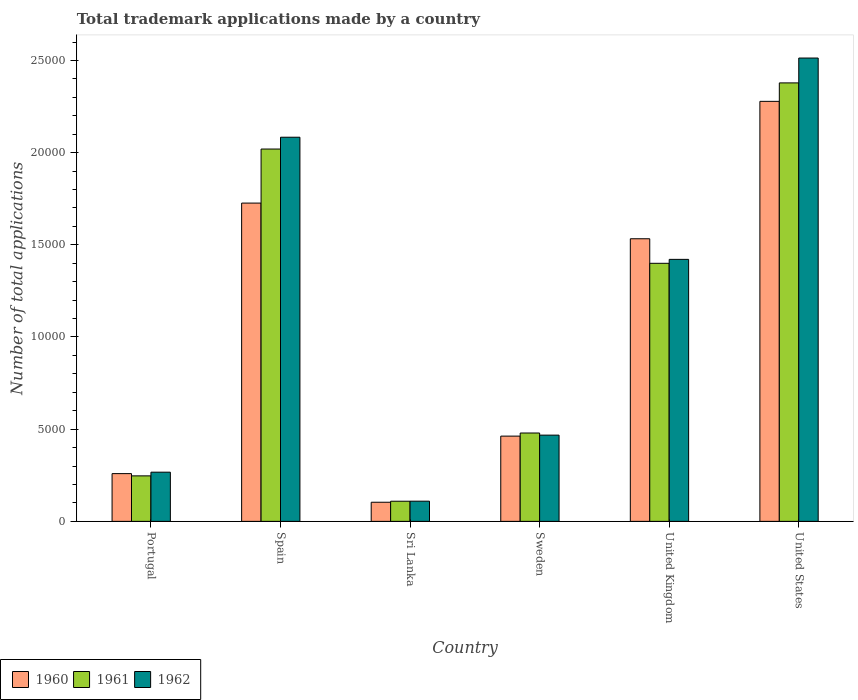How many groups of bars are there?
Offer a terse response. 6. How many bars are there on the 3rd tick from the right?
Give a very brief answer. 3. What is the label of the 2nd group of bars from the left?
Give a very brief answer. Spain. In how many cases, is the number of bars for a given country not equal to the number of legend labels?
Provide a short and direct response. 0. What is the number of applications made by in 1960 in Sweden?
Ensure brevity in your answer.  4624. Across all countries, what is the maximum number of applications made by in 1961?
Offer a very short reply. 2.38e+04. Across all countries, what is the minimum number of applications made by in 1960?
Offer a terse response. 1037. In which country was the number of applications made by in 1961 maximum?
Your answer should be compact. United States. In which country was the number of applications made by in 1960 minimum?
Your answer should be compact. Sri Lanka. What is the total number of applications made by in 1960 in the graph?
Provide a short and direct response. 6.36e+04. What is the difference between the number of applications made by in 1961 in Spain and that in Sweden?
Offer a very short reply. 1.54e+04. What is the difference between the number of applications made by in 1962 in Portugal and the number of applications made by in 1961 in United Kingdom?
Provide a succinct answer. -1.13e+04. What is the average number of applications made by in 1960 per country?
Keep it short and to the point. 1.06e+04. What is the difference between the number of applications made by of/in 1962 and number of applications made by of/in 1961 in Portugal?
Ensure brevity in your answer.  200. What is the ratio of the number of applications made by in 1962 in Portugal to that in Sweden?
Offer a terse response. 0.57. Is the difference between the number of applications made by in 1962 in Spain and Sri Lanka greater than the difference between the number of applications made by in 1961 in Spain and Sri Lanka?
Your answer should be compact. Yes. What is the difference between the highest and the second highest number of applications made by in 1961?
Give a very brief answer. 6197. What is the difference between the highest and the lowest number of applications made by in 1961?
Make the answer very short. 2.27e+04. Is the sum of the number of applications made by in 1961 in Sweden and United Kingdom greater than the maximum number of applications made by in 1960 across all countries?
Give a very brief answer. No. What does the 3rd bar from the right in Spain represents?
Provide a succinct answer. 1960. How many bars are there?
Offer a very short reply. 18. Are all the bars in the graph horizontal?
Offer a terse response. No. How many countries are there in the graph?
Ensure brevity in your answer.  6. Where does the legend appear in the graph?
Make the answer very short. Bottom left. How many legend labels are there?
Give a very brief answer. 3. What is the title of the graph?
Your answer should be compact. Total trademark applications made by a country. What is the label or title of the Y-axis?
Your response must be concise. Number of total applications. What is the Number of total applications in 1960 in Portugal?
Make the answer very short. 2590. What is the Number of total applications in 1961 in Portugal?
Ensure brevity in your answer.  2468. What is the Number of total applications of 1962 in Portugal?
Give a very brief answer. 2668. What is the Number of total applications in 1960 in Spain?
Provide a succinct answer. 1.73e+04. What is the Number of total applications in 1961 in Spain?
Your answer should be compact. 2.02e+04. What is the Number of total applications of 1962 in Spain?
Your response must be concise. 2.08e+04. What is the Number of total applications of 1960 in Sri Lanka?
Keep it short and to the point. 1037. What is the Number of total applications in 1961 in Sri Lanka?
Make the answer very short. 1092. What is the Number of total applications of 1962 in Sri Lanka?
Offer a very short reply. 1095. What is the Number of total applications of 1960 in Sweden?
Offer a very short reply. 4624. What is the Number of total applications in 1961 in Sweden?
Give a very brief answer. 4792. What is the Number of total applications in 1962 in Sweden?
Provide a short and direct response. 4677. What is the Number of total applications in 1960 in United Kingdom?
Make the answer very short. 1.53e+04. What is the Number of total applications in 1961 in United Kingdom?
Your answer should be very brief. 1.40e+04. What is the Number of total applications of 1962 in United Kingdom?
Ensure brevity in your answer.  1.42e+04. What is the Number of total applications of 1960 in United States?
Give a very brief answer. 2.28e+04. What is the Number of total applications in 1961 in United States?
Make the answer very short. 2.38e+04. What is the Number of total applications of 1962 in United States?
Your answer should be compact. 2.51e+04. Across all countries, what is the maximum Number of total applications of 1960?
Keep it short and to the point. 2.28e+04. Across all countries, what is the maximum Number of total applications in 1961?
Provide a short and direct response. 2.38e+04. Across all countries, what is the maximum Number of total applications in 1962?
Your answer should be very brief. 2.51e+04. Across all countries, what is the minimum Number of total applications of 1960?
Your answer should be very brief. 1037. Across all countries, what is the minimum Number of total applications of 1961?
Give a very brief answer. 1092. Across all countries, what is the minimum Number of total applications of 1962?
Make the answer very short. 1095. What is the total Number of total applications in 1960 in the graph?
Keep it short and to the point. 6.36e+04. What is the total Number of total applications of 1961 in the graph?
Make the answer very short. 6.63e+04. What is the total Number of total applications in 1962 in the graph?
Give a very brief answer. 6.86e+04. What is the difference between the Number of total applications in 1960 in Portugal and that in Spain?
Provide a succinct answer. -1.47e+04. What is the difference between the Number of total applications of 1961 in Portugal and that in Spain?
Your response must be concise. -1.77e+04. What is the difference between the Number of total applications in 1962 in Portugal and that in Spain?
Ensure brevity in your answer.  -1.82e+04. What is the difference between the Number of total applications in 1960 in Portugal and that in Sri Lanka?
Your answer should be very brief. 1553. What is the difference between the Number of total applications in 1961 in Portugal and that in Sri Lanka?
Offer a very short reply. 1376. What is the difference between the Number of total applications of 1962 in Portugal and that in Sri Lanka?
Offer a terse response. 1573. What is the difference between the Number of total applications in 1960 in Portugal and that in Sweden?
Give a very brief answer. -2034. What is the difference between the Number of total applications of 1961 in Portugal and that in Sweden?
Give a very brief answer. -2324. What is the difference between the Number of total applications of 1962 in Portugal and that in Sweden?
Your response must be concise. -2009. What is the difference between the Number of total applications of 1960 in Portugal and that in United Kingdom?
Give a very brief answer. -1.27e+04. What is the difference between the Number of total applications in 1961 in Portugal and that in United Kingdom?
Your response must be concise. -1.15e+04. What is the difference between the Number of total applications in 1962 in Portugal and that in United Kingdom?
Keep it short and to the point. -1.15e+04. What is the difference between the Number of total applications of 1960 in Portugal and that in United States?
Offer a terse response. -2.02e+04. What is the difference between the Number of total applications of 1961 in Portugal and that in United States?
Provide a short and direct response. -2.13e+04. What is the difference between the Number of total applications in 1962 in Portugal and that in United States?
Your response must be concise. -2.25e+04. What is the difference between the Number of total applications in 1960 in Spain and that in Sri Lanka?
Provide a short and direct response. 1.62e+04. What is the difference between the Number of total applications of 1961 in Spain and that in Sri Lanka?
Ensure brevity in your answer.  1.91e+04. What is the difference between the Number of total applications in 1962 in Spain and that in Sri Lanka?
Provide a succinct answer. 1.97e+04. What is the difference between the Number of total applications in 1960 in Spain and that in Sweden?
Your answer should be very brief. 1.26e+04. What is the difference between the Number of total applications of 1961 in Spain and that in Sweden?
Provide a succinct answer. 1.54e+04. What is the difference between the Number of total applications in 1962 in Spain and that in Sweden?
Your answer should be very brief. 1.62e+04. What is the difference between the Number of total applications in 1960 in Spain and that in United Kingdom?
Keep it short and to the point. 1935. What is the difference between the Number of total applications of 1961 in Spain and that in United Kingdom?
Offer a very short reply. 6197. What is the difference between the Number of total applications in 1962 in Spain and that in United Kingdom?
Ensure brevity in your answer.  6625. What is the difference between the Number of total applications in 1960 in Spain and that in United States?
Offer a very short reply. -5518. What is the difference between the Number of total applications of 1961 in Spain and that in United States?
Provide a short and direct response. -3588. What is the difference between the Number of total applications in 1962 in Spain and that in United States?
Your response must be concise. -4295. What is the difference between the Number of total applications in 1960 in Sri Lanka and that in Sweden?
Your response must be concise. -3587. What is the difference between the Number of total applications in 1961 in Sri Lanka and that in Sweden?
Offer a terse response. -3700. What is the difference between the Number of total applications in 1962 in Sri Lanka and that in Sweden?
Your answer should be compact. -3582. What is the difference between the Number of total applications in 1960 in Sri Lanka and that in United Kingdom?
Provide a short and direct response. -1.43e+04. What is the difference between the Number of total applications in 1961 in Sri Lanka and that in United Kingdom?
Provide a succinct answer. -1.29e+04. What is the difference between the Number of total applications in 1962 in Sri Lanka and that in United Kingdom?
Ensure brevity in your answer.  -1.31e+04. What is the difference between the Number of total applications of 1960 in Sri Lanka and that in United States?
Keep it short and to the point. -2.17e+04. What is the difference between the Number of total applications in 1961 in Sri Lanka and that in United States?
Provide a succinct answer. -2.27e+04. What is the difference between the Number of total applications of 1962 in Sri Lanka and that in United States?
Make the answer very short. -2.40e+04. What is the difference between the Number of total applications in 1960 in Sweden and that in United Kingdom?
Make the answer very short. -1.07e+04. What is the difference between the Number of total applications in 1961 in Sweden and that in United Kingdom?
Make the answer very short. -9205. What is the difference between the Number of total applications in 1962 in Sweden and that in United Kingdom?
Make the answer very short. -9533. What is the difference between the Number of total applications in 1960 in Sweden and that in United States?
Make the answer very short. -1.82e+04. What is the difference between the Number of total applications of 1961 in Sweden and that in United States?
Offer a very short reply. -1.90e+04. What is the difference between the Number of total applications of 1962 in Sweden and that in United States?
Offer a terse response. -2.05e+04. What is the difference between the Number of total applications of 1960 in United Kingdom and that in United States?
Your answer should be compact. -7453. What is the difference between the Number of total applications in 1961 in United Kingdom and that in United States?
Your answer should be very brief. -9785. What is the difference between the Number of total applications in 1962 in United Kingdom and that in United States?
Your response must be concise. -1.09e+04. What is the difference between the Number of total applications of 1960 in Portugal and the Number of total applications of 1961 in Spain?
Ensure brevity in your answer.  -1.76e+04. What is the difference between the Number of total applications in 1960 in Portugal and the Number of total applications in 1962 in Spain?
Ensure brevity in your answer.  -1.82e+04. What is the difference between the Number of total applications in 1961 in Portugal and the Number of total applications in 1962 in Spain?
Keep it short and to the point. -1.84e+04. What is the difference between the Number of total applications in 1960 in Portugal and the Number of total applications in 1961 in Sri Lanka?
Your response must be concise. 1498. What is the difference between the Number of total applications of 1960 in Portugal and the Number of total applications of 1962 in Sri Lanka?
Offer a terse response. 1495. What is the difference between the Number of total applications of 1961 in Portugal and the Number of total applications of 1962 in Sri Lanka?
Keep it short and to the point. 1373. What is the difference between the Number of total applications in 1960 in Portugal and the Number of total applications in 1961 in Sweden?
Ensure brevity in your answer.  -2202. What is the difference between the Number of total applications in 1960 in Portugal and the Number of total applications in 1962 in Sweden?
Provide a short and direct response. -2087. What is the difference between the Number of total applications of 1961 in Portugal and the Number of total applications of 1962 in Sweden?
Your answer should be very brief. -2209. What is the difference between the Number of total applications in 1960 in Portugal and the Number of total applications in 1961 in United Kingdom?
Give a very brief answer. -1.14e+04. What is the difference between the Number of total applications of 1960 in Portugal and the Number of total applications of 1962 in United Kingdom?
Give a very brief answer. -1.16e+04. What is the difference between the Number of total applications in 1961 in Portugal and the Number of total applications in 1962 in United Kingdom?
Your answer should be compact. -1.17e+04. What is the difference between the Number of total applications of 1960 in Portugal and the Number of total applications of 1961 in United States?
Your response must be concise. -2.12e+04. What is the difference between the Number of total applications in 1960 in Portugal and the Number of total applications in 1962 in United States?
Keep it short and to the point. -2.25e+04. What is the difference between the Number of total applications in 1961 in Portugal and the Number of total applications in 1962 in United States?
Ensure brevity in your answer.  -2.27e+04. What is the difference between the Number of total applications of 1960 in Spain and the Number of total applications of 1961 in Sri Lanka?
Ensure brevity in your answer.  1.62e+04. What is the difference between the Number of total applications of 1960 in Spain and the Number of total applications of 1962 in Sri Lanka?
Your answer should be very brief. 1.62e+04. What is the difference between the Number of total applications of 1961 in Spain and the Number of total applications of 1962 in Sri Lanka?
Your answer should be very brief. 1.91e+04. What is the difference between the Number of total applications in 1960 in Spain and the Number of total applications in 1961 in Sweden?
Offer a very short reply. 1.25e+04. What is the difference between the Number of total applications in 1960 in Spain and the Number of total applications in 1962 in Sweden?
Offer a very short reply. 1.26e+04. What is the difference between the Number of total applications in 1961 in Spain and the Number of total applications in 1962 in Sweden?
Ensure brevity in your answer.  1.55e+04. What is the difference between the Number of total applications of 1960 in Spain and the Number of total applications of 1961 in United Kingdom?
Your answer should be compact. 3266. What is the difference between the Number of total applications in 1960 in Spain and the Number of total applications in 1962 in United Kingdom?
Your answer should be very brief. 3053. What is the difference between the Number of total applications in 1961 in Spain and the Number of total applications in 1962 in United Kingdom?
Give a very brief answer. 5984. What is the difference between the Number of total applications of 1960 in Spain and the Number of total applications of 1961 in United States?
Offer a very short reply. -6519. What is the difference between the Number of total applications in 1960 in Spain and the Number of total applications in 1962 in United States?
Give a very brief answer. -7867. What is the difference between the Number of total applications in 1961 in Spain and the Number of total applications in 1962 in United States?
Give a very brief answer. -4936. What is the difference between the Number of total applications of 1960 in Sri Lanka and the Number of total applications of 1961 in Sweden?
Give a very brief answer. -3755. What is the difference between the Number of total applications in 1960 in Sri Lanka and the Number of total applications in 1962 in Sweden?
Provide a succinct answer. -3640. What is the difference between the Number of total applications of 1961 in Sri Lanka and the Number of total applications of 1962 in Sweden?
Your answer should be compact. -3585. What is the difference between the Number of total applications of 1960 in Sri Lanka and the Number of total applications of 1961 in United Kingdom?
Make the answer very short. -1.30e+04. What is the difference between the Number of total applications of 1960 in Sri Lanka and the Number of total applications of 1962 in United Kingdom?
Make the answer very short. -1.32e+04. What is the difference between the Number of total applications in 1961 in Sri Lanka and the Number of total applications in 1962 in United Kingdom?
Provide a short and direct response. -1.31e+04. What is the difference between the Number of total applications of 1960 in Sri Lanka and the Number of total applications of 1961 in United States?
Ensure brevity in your answer.  -2.27e+04. What is the difference between the Number of total applications in 1960 in Sri Lanka and the Number of total applications in 1962 in United States?
Your answer should be very brief. -2.41e+04. What is the difference between the Number of total applications of 1961 in Sri Lanka and the Number of total applications of 1962 in United States?
Offer a very short reply. -2.40e+04. What is the difference between the Number of total applications of 1960 in Sweden and the Number of total applications of 1961 in United Kingdom?
Your answer should be very brief. -9373. What is the difference between the Number of total applications in 1960 in Sweden and the Number of total applications in 1962 in United Kingdom?
Keep it short and to the point. -9586. What is the difference between the Number of total applications of 1961 in Sweden and the Number of total applications of 1962 in United Kingdom?
Offer a very short reply. -9418. What is the difference between the Number of total applications in 1960 in Sweden and the Number of total applications in 1961 in United States?
Your response must be concise. -1.92e+04. What is the difference between the Number of total applications of 1960 in Sweden and the Number of total applications of 1962 in United States?
Your answer should be compact. -2.05e+04. What is the difference between the Number of total applications in 1961 in Sweden and the Number of total applications in 1962 in United States?
Offer a very short reply. -2.03e+04. What is the difference between the Number of total applications of 1960 in United Kingdom and the Number of total applications of 1961 in United States?
Make the answer very short. -8454. What is the difference between the Number of total applications in 1960 in United Kingdom and the Number of total applications in 1962 in United States?
Your answer should be compact. -9802. What is the difference between the Number of total applications of 1961 in United Kingdom and the Number of total applications of 1962 in United States?
Make the answer very short. -1.11e+04. What is the average Number of total applications in 1960 per country?
Provide a short and direct response. 1.06e+04. What is the average Number of total applications of 1961 per country?
Offer a terse response. 1.11e+04. What is the average Number of total applications in 1962 per country?
Offer a very short reply. 1.14e+04. What is the difference between the Number of total applications in 1960 and Number of total applications in 1961 in Portugal?
Make the answer very short. 122. What is the difference between the Number of total applications in 1960 and Number of total applications in 1962 in Portugal?
Your response must be concise. -78. What is the difference between the Number of total applications in 1961 and Number of total applications in 1962 in Portugal?
Your answer should be very brief. -200. What is the difference between the Number of total applications in 1960 and Number of total applications in 1961 in Spain?
Your answer should be very brief. -2931. What is the difference between the Number of total applications of 1960 and Number of total applications of 1962 in Spain?
Offer a terse response. -3572. What is the difference between the Number of total applications of 1961 and Number of total applications of 1962 in Spain?
Give a very brief answer. -641. What is the difference between the Number of total applications of 1960 and Number of total applications of 1961 in Sri Lanka?
Give a very brief answer. -55. What is the difference between the Number of total applications in 1960 and Number of total applications in 1962 in Sri Lanka?
Ensure brevity in your answer.  -58. What is the difference between the Number of total applications of 1960 and Number of total applications of 1961 in Sweden?
Your answer should be compact. -168. What is the difference between the Number of total applications in 1960 and Number of total applications in 1962 in Sweden?
Offer a very short reply. -53. What is the difference between the Number of total applications in 1961 and Number of total applications in 1962 in Sweden?
Give a very brief answer. 115. What is the difference between the Number of total applications of 1960 and Number of total applications of 1961 in United Kingdom?
Offer a terse response. 1331. What is the difference between the Number of total applications in 1960 and Number of total applications in 1962 in United Kingdom?
Provide a succinct answer. 1118. What is the difference between the Number of total applications of 1961 and Number of total applications of 1962 in United Kingdom?
Give a very brief answer. -213. What is the difference between the Number of total applications of 1960 and Number of total applications of 1961 in United States?
Offer a terse response. -1001. What is the difference between the Number of total applications in 1960 and Number of total applications in 1962 in United States?
Your answer should be very brief. -2349. What is the difference between the Number of total applications in 1961 and Number of total applications in 1962 in United States?
Provide a succinct answer. -1348. What is the ratio of the Number of total applications of 1960 in Portugal to that in Spain?
Your answer should be compact. 0.15. What is the ratio of the Number of total applications of 1961 in Portugal to that in Spain?
Offer a terse response. 0.12. What is the ratio of the Number of total applications of 1962 in Portugal to that in Spain?
Ensure brevity in your answer.  0.13. What is the ratio of the Number of total applications of 1960 in Portugal to that in Sri Lanka?
Offer a terse response. 2.5. What is the ratio of the Number of total applications in 1961 in Portugal to that in Sri Lanka?
Your answer should be very brief. 2.26. What is the ratio of the Number of total applications in 1962 in Portugal to that in Sri Lanka?
Your answer should be compact. 2.44. What is the ratio of the Number of total applications of 1960 in Portugal to that in Sweden?
Provide a short and direct response. 0.56. What is the ratio of the Number of total applications in 1961 in Portugal to that in Sweden?
Your response must be concise. 0.52. What is the ratio of the Number of total applications of 1962 in Portugal to that in Sweden?
Ensure brevity in your answer.  0.57. What is the ratio of the Number of total applications of 1960 in Portugal to that in United Kingdom?
Make the answer very short. 0.17. What is the ratio of the Number of total applications in 1961 in Portugal to that in United Kingdom?
Keep it short and to the point. 0.18. What is the ratio of the Number of total applications of 1962 in Portugal to that in United Kingdom?
Your response must be concise. 0.19. What is the ratio of the Number of total applications in 1960 in Portugal to that in United States?
Ensure brevity in your answer.  0.11. What is the ratio of the Number of total applications in 1961 in Portugal to that in United States?
Make the answer very short. 0.1. What is the ratio of the Number of total applications in 1962 in Portugal to that in United States?
Ensure brevity in your answer.  0.11. What is the ratio of the Number of total applications of 1960 in Spain to that in Sri Lanka?
Your answer should be very brief. 16.65. What is the ratio of the Number of total applications in 1961 in Spain to that in Sri Lanka?
Offer a terse response. 18.49. What is the ratio of the Number of total applications of 1962 in Spain to that in Sri Lanka?
Keep it short and to the point. 19.03. What is the ratio of the Number of total applications in 1960 in Spain to that in Sweden?
Provide a succinct answer. 3.73. What is the ratio of the Number of total applications in 1961 in Spain to that in Sweden?
Offer a very short reply. 4.21. What is the ratio of the Number of total applications in 1962 in Spain to that in Sweden?
Provide a succinct answer. 4.45. What is the ratio of the Number of total applications in 1960 in Spain to that in United Kingdom?
Make the answer very short. 1.13. What is the ratio of the Number of total applications in 1961 in Spain to that in United Kingdom?
Offer a terse response. 1.44. What is the ratio of the Number of total applications of 1962 in Spain to that in United Kingdom?
Your answer should be compact. 1.47. What is the ratio of the Number of total applications in 1960 in Spain to that in United States?
Provide a short and direct response. 0.76. What is the ratio of the Number of total applications in 1961 in Spain to that in United States?
Give a very brief answer. 0.85. What is the ratio of the Number of total applications of 1962 in Spain to that in United States?
Your answer should be very brief. 0.83. What is the ratio of the Number of total applications of 1960 in Sri Lanka to that in Sweden?
Your answer should be very brief. 0.22. What is the ratio of the Number of total applications of 1961 in Sri Lanka to that in Sweden?
Ensure brevity in your answer.  0.23. What is the ratio of the Number of total applications of 1962 in Sri Lanka to that in Sweden?
Offer a very short reply. 0.23. What is the ratio of the Number of total applications of 1960 in Sri Lanka to that in United Kingdom?
Make the answer very short. 0.07. What is the ratio of the Number of total applications of 1961 in Sri Lanka to that in United Kingdom?
Give a very brief answer. 0.08. What is the ratio of the Number of total applications of 1962 in Sri Lanka to that in United Kingdom?
Provide a short and direct response. 0.08. What is the ratio of the Number of total applications in 1960 in Sri Lanka to that in United States?
Make the answer very short. 0.05. What is the ratio of the Number of total applications in 1961 in Sri Lanka to that in United States?
Your answer should be compact. 0.05. What is the ratio of the Number of total applications in 1962 in Sri Lanka to that in United States?
Offer a very short reply. 0.04. What is the ratio of the Number of total applications of 1960 in Sweden to that in United Kingdom?
Offer a terse response. 0.3. What is the ratio of the Number of total applications of 1961 in Sweden to that in United Kingdom?
Your response must be concise. 0.34. What is the ratio of the Number of total applications in 1962 in Sweden to that in United Kingdom?
Keep it short and to the point. 0.33. What is the ratio of the Number of total applications in 1960 in Sweden to that in United States?
Your answer should be compact. 0.2. What is the ratio of the Number of total applications in 1961 in Sweden to that in United States?
Your response must be concise. 0.2. What is the ratio of the Number of total applications of 1962 in Sweden to that in United States?
Provide a short and direct response. 0.19. What is the ratio of the Number of total applications of 1960 in United Kingdom to that in United States?
Give a very brief answer. 0.67. What is the ratio of the Number of total applications of 1961 in United Kingdom to that in United States?
Give a very brief answer. 0.59. What is the ratio of the Number of total applications in 1962 in United Kingdom to that in United States?
Give a very brief answer. 0.57. What is the difference between the highest and the second highest Number of total applications in 1960?
Your answer should be compact. 5518. What is the difference between the highest and the second highest Number of total applications of 1961?
Your answer should be very brief. 3588. What is the difference between the highest and the second highest Number of total applications of 1962?
Your response must be concise. 4295. What is the difference between the highest and the lowest Number of total applications in 1960?
Provide a succinct answer. 2.17e+04. What is the difference between the highest and the lowest Number of total applications in 1961?
Offer a very short reply. 2.27e+04. What is the difference between the highest and the lowest Number of total applications in 1962?
Provide a short and direct response. 2.40e+04. 